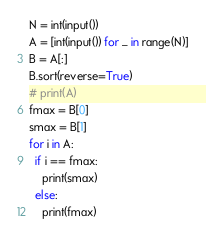<code> <loc_0><loc_0><loc_500><loc_500><_Python_>N = int(input())
A = [int(input()) for _ in range(N)]
B = A[:]
B.sort(reverse=True)
# print(A)
fmax = B[0]
smax = B[1]
for i in A:
  if i == fmax:
    print(smax)
  else:
    print(fmax)</code> 